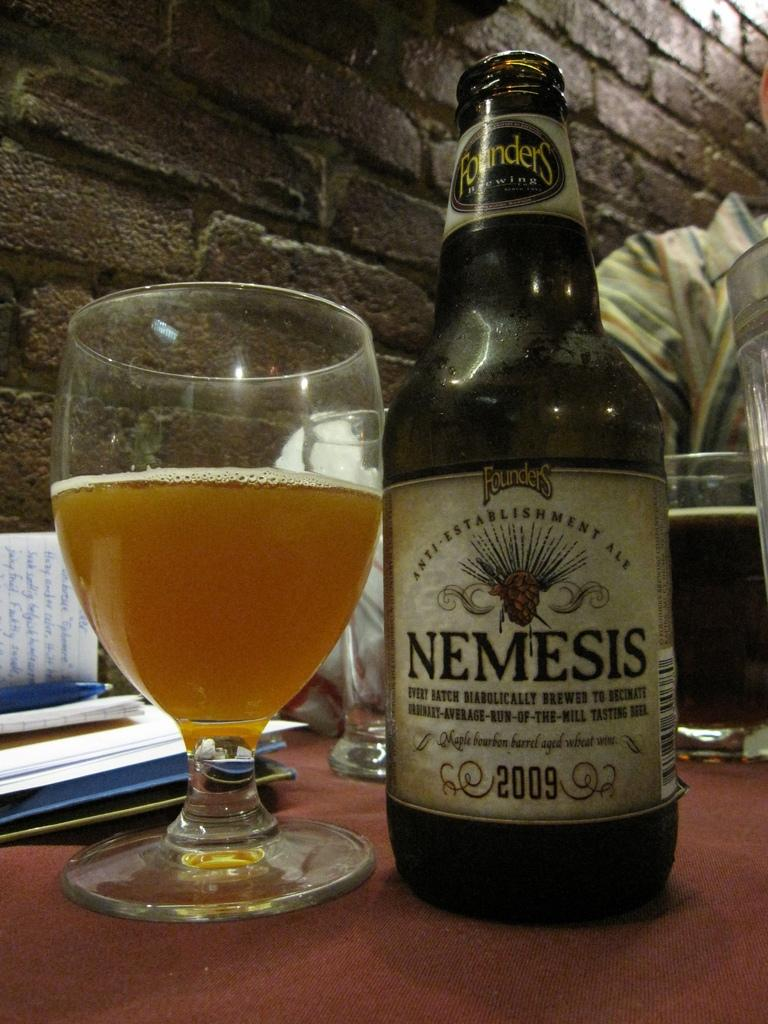<image>
Give a short and clear explanation of the subsequent image. A glass of Nemesis beer placed next to a bottle of Nemesis beer. 